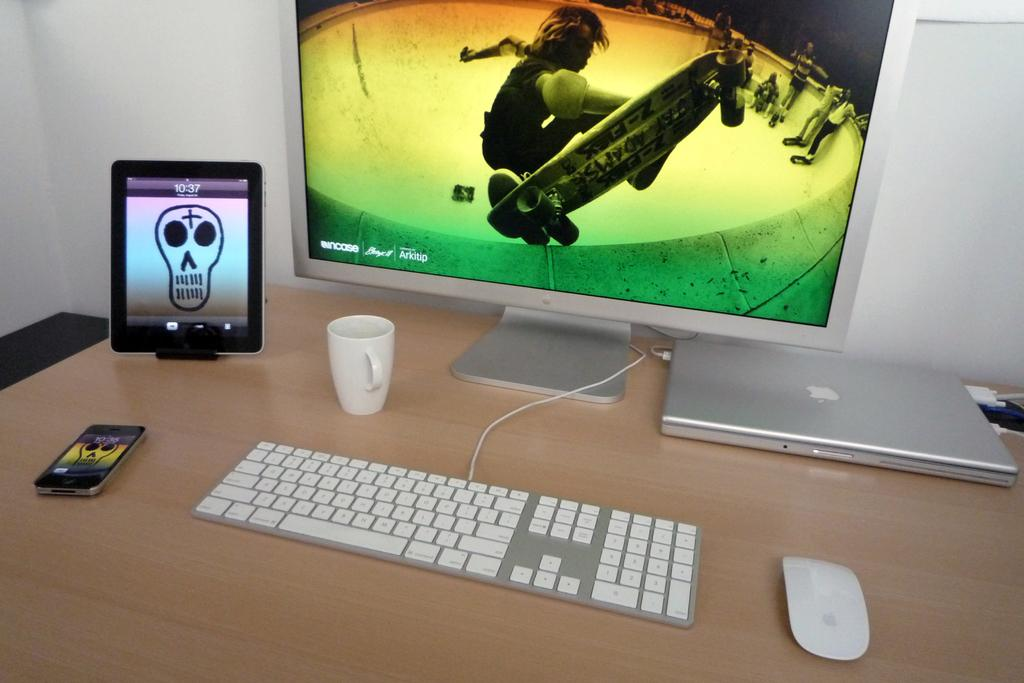<image>
Share a concise interpretation of the image provided. A computer desk with many electronics on it, one such being a tablet displaying the time as 10:37. 